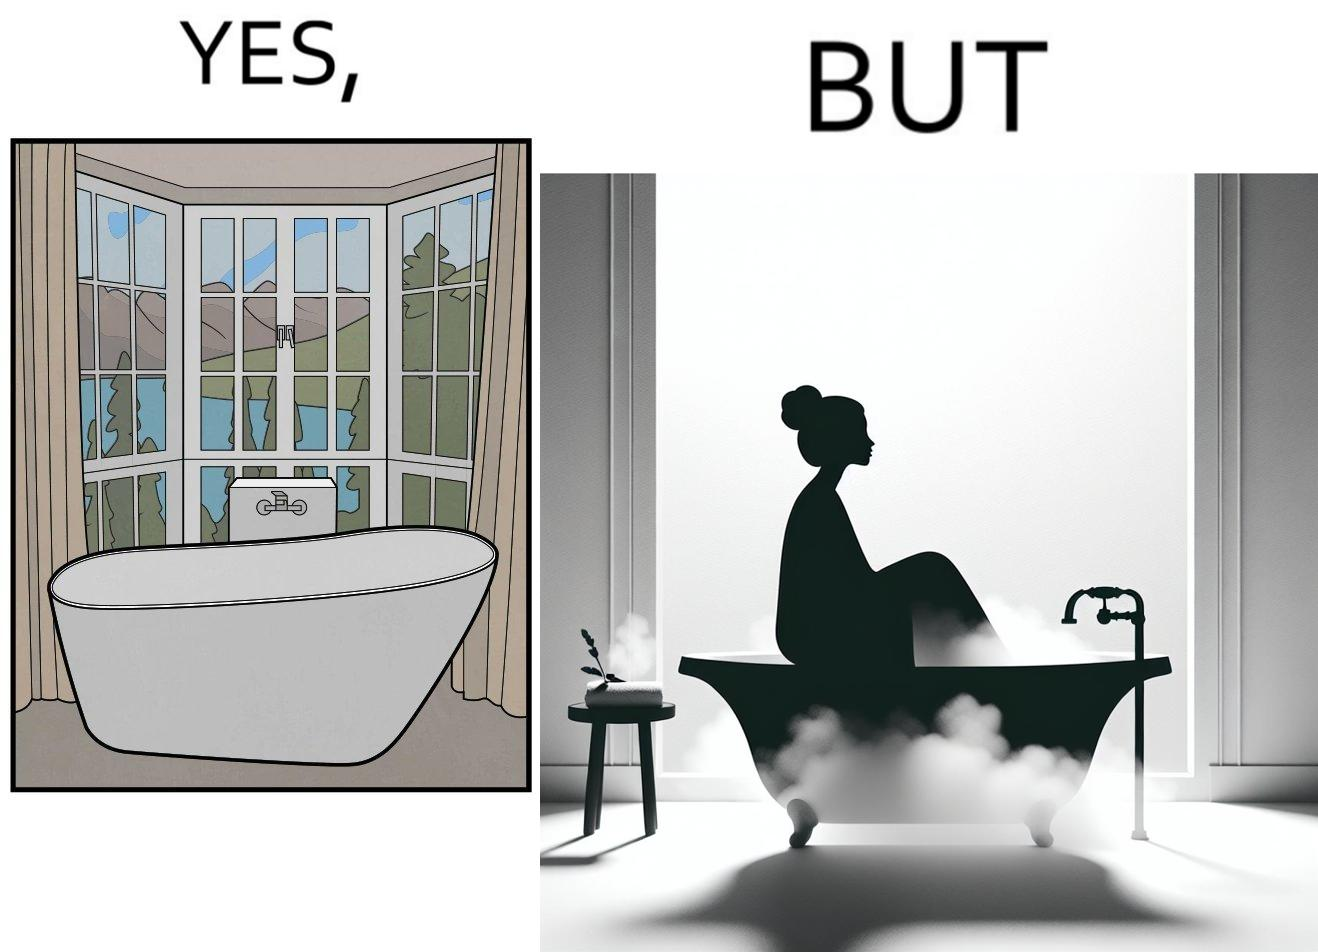Compare the left and right sides of this image. In the left part of the image: a bathtub by the side of a window which has a very scenic view of lake and mountains. In the right part of the image: a woman bathing in a bathtub, while the window glasses are foggy from the steam of the hot water. 